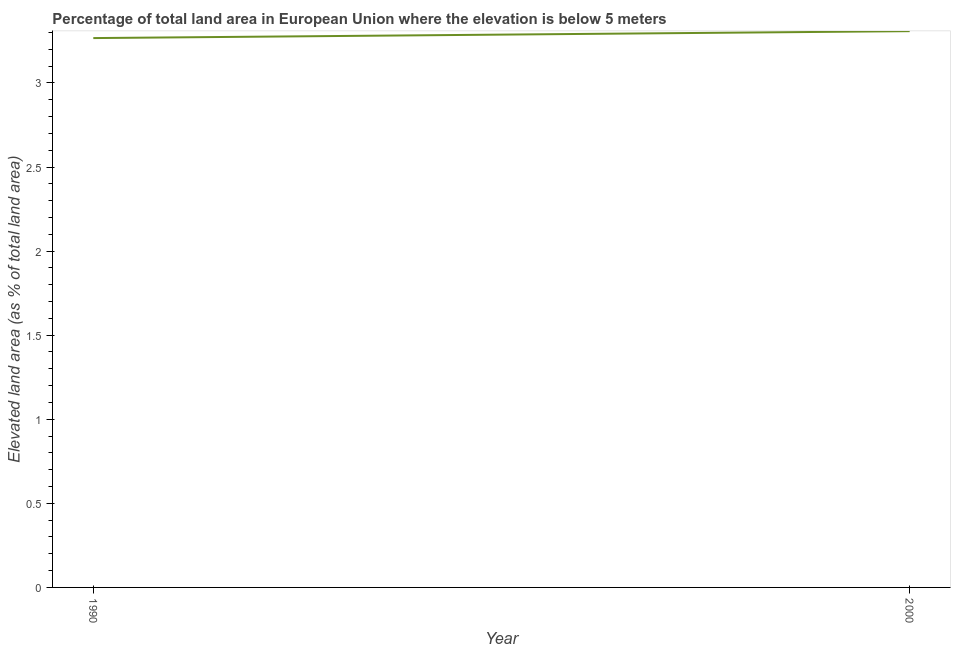What is the total elevated land area in 2000?
Give a very brief answer. 3.31. Across all years, what is the maximum total elevated land area?
Make the answer very short. 3.31. Across all years, what is the minimum total elevated land area?
Provide a succinct answer. 3.27. What is the sum of the total elevated land area?
Your answer should be very brief. 6.57. What is the difference between the total elevated land area in 1990 and 2000?
Make the answer very short. -0.04. What is the average total elevated land area per year?
Your answer should be very brief. 3.29. What is the median total elevated land area?
Provide a succinct answer. 3.29. What is the ratio of the total elevated land area in 1990 to that in 2000?
Your answer should be compact. 0.99. In how many years, is the total elevated land area greater than the average total elevated land area taken over all years?
Make the answer very short. 1. What is the difference between two consecutive major ticks on the Y-axis?
Give a very brief answer. 0.5. What is the title of the graph?
Keep it short and to the point. Percentage of total land area in European Union where the elevation is below 5 meters. What is the label or title of the Y-axis?
Keep it short and to the point. Elevated land area (as % of total land area). What is the Elevated land area (as % of total land area) of 1990?
Keep it short and to the point. 3.27. What is the Elevated land area (as % of total land area) of 2000?
Your answer should be compact. 3.31. What is the difference between the Elevated land area (as % of total land area) in 1990 and 2000?
Provide a short and direct response. -0.04. What is the ratio of the Elevated land area (as % of total land area) in 1990 to that in 2000?
Give a very brief answer. 0.99. 